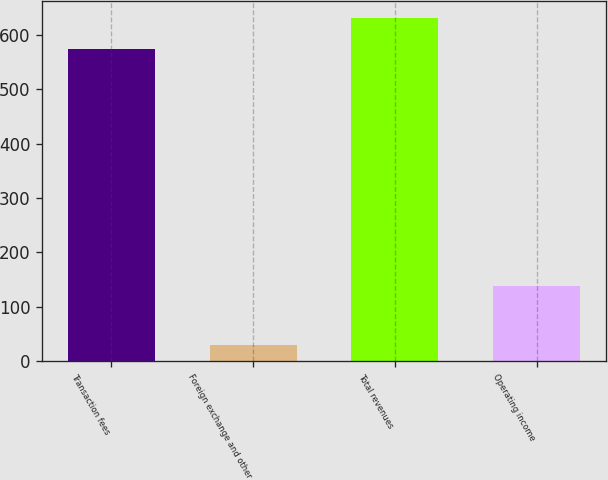Convert chart. <chart><loc_0><loc_0><loc_500><loc_500><bar_chart><fcel>Transaction fees<fcel>Foreign exchange and other<fcel>Total revenues<fcel>Operating income<nl><fcel>573.6<fcel>30.3<fcel>630.96<fcel>137.6<nl></chart> 